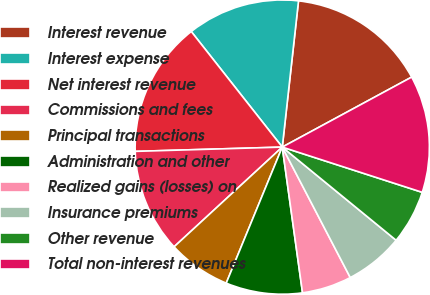Convert chart to OTSL. <chart><loc_0><loc_0><loc_500><loc_500><pie_chart><fcel>Interest revenue<fcel>Interest expense<fcel>Net interest revenue<fcel>Commissions and fees<fcel>Principal transactions<fcel>Administration and other<fcel>Realized gains (losses) on<fcel>Insurance premiums<fcel>Other revenue<fcel>Total non-interest revenues<nl><fcel>15.35%<fcel>12.38%<fcel>14.85%<fcel>11.39%<fcel>6.93%<fcel>8.42%<fcel>5.45%<fcel>6.44%<fcel>5.94%<fcel>12.87%<nl></chart> 